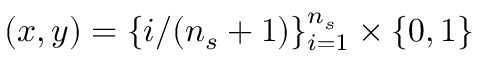<formula> <loc_0><loc_0><loc_500><loc_500>( x , y ) = \{ i / ( n _ { s } + 1 ) \} _ { i = 1 } ^ { n _ { s } } \times \{ 0 , 1 \}</formula> 